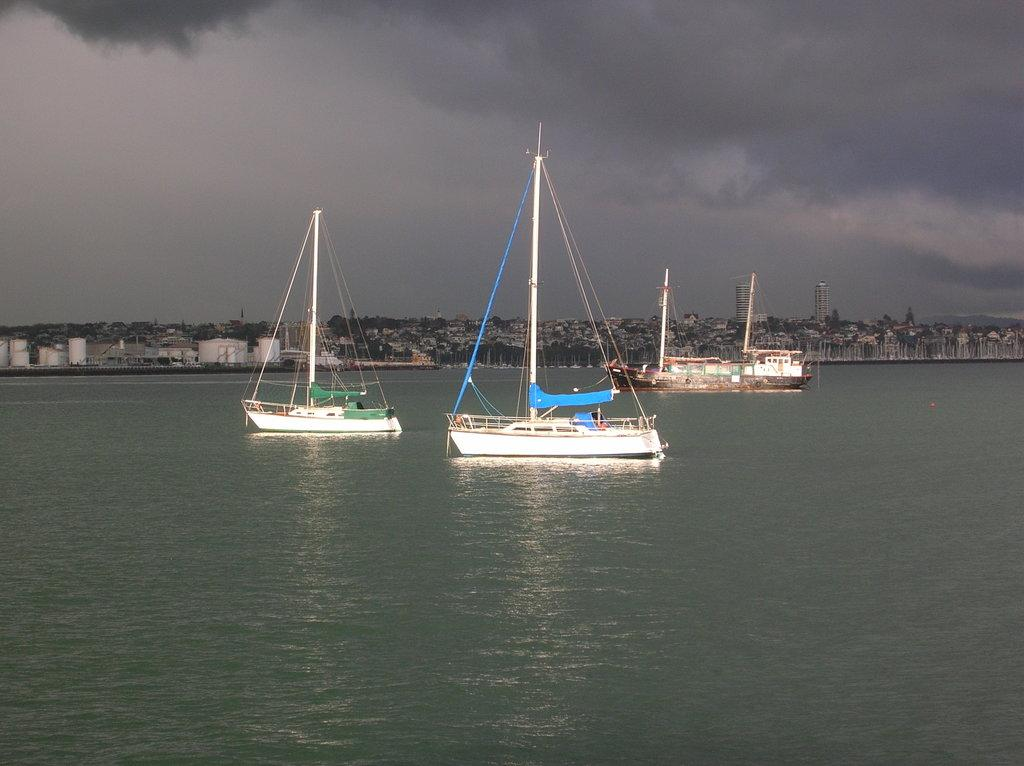What is the primary element in the image? There is water in the image. What else can be seen in the water? There are boats in the image. What structures are visible in the image? There are buildings in the image. What is visible at the top of the image? The sky is visible at the top of the image. What can be observed in the sky? Clouds are present in the sky. How many cakes are being baked in the town shown in the image? There is no town or cakes present in the image; it features water, boats, buildings, and a sky with clouds. 